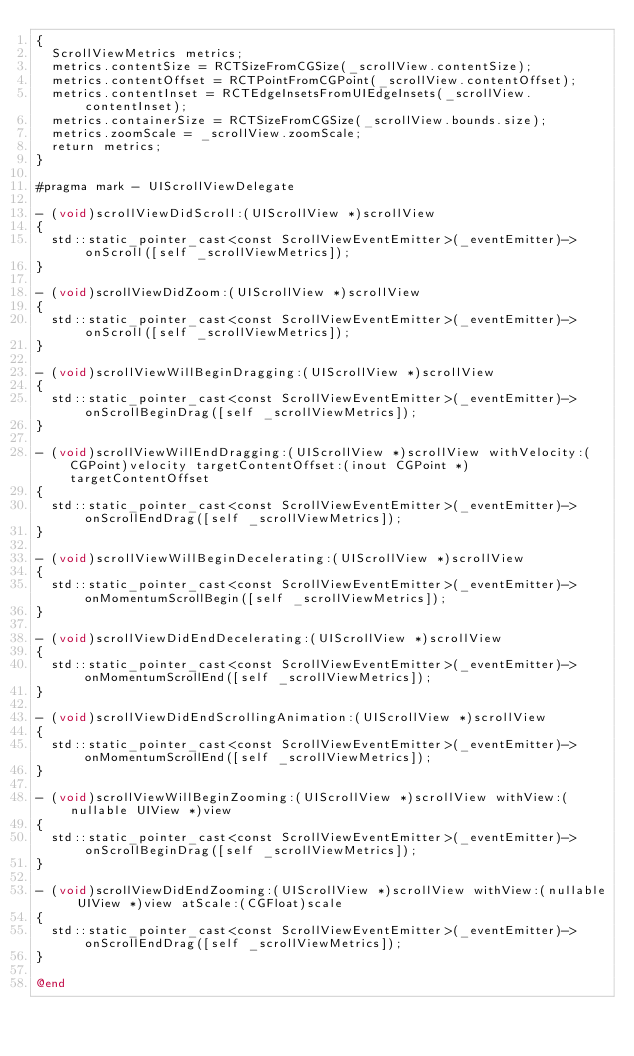Convert code to text. <code><loc_0><loc_0><loc_500><loc_500><_ObjectiveC_>{
  ScrollViewMetrics metrics;
  metrics.contentSize = RCTSizeFromCGSize(_scrollView.contentSize);
  metrics.contentOffset = RCTPointFromCGPoint(_scrollView.contentOffset);
  metrics.contentInset = RCTEdgeInsetsFromUIEdgeInsets(_scrollView.contentInset);
  metrics.containerSize = RCTSizeFromCGSize(_scrollView.bounds.size);
  metrics.zoomScale = _scrollView.zoomScale;
  return metrics;
}

#pragma mark - UIScrollViewDelegate

- (void)scrollViewDidScroll:(UIScrollView *)scrollView
{
  std::static_pointer_cast<const ScrollViewEventEmitter>(_eventEmitter)->onScroll([self _scrollViewMetrics]);
}

- (void)scrollViewDidZoom:(UIScrollView *)scrollView
{
  std::static_pointer_cast<const ScrollViewEventEmitter>(_eventEmitter)->onScroll([self _scrollViewMetrics]);
}

- (void)scrollViewWillBeginDragging:(UIScrollView *)scrollView
{
  std::static_pointer_cast<const ScrollViewEventEmitter>(_eventEmitter)->onScrollBeginDrag([self _scrollViewMetrics]);
}

- (void)scrollViewWillEndDragging:(UIScrollView *)scrollView withVelocity:(CGPoint)velocity targetContentOffset:(inout CGPoint *)targetContentOffset
{
  std::static_pointer_cast<const ScrollViewEventEmitter>(_eventEmitter)->onScrollEndDrag([self _scrollViewMetrics]);
}

- (void)scrollViewWillBeginDecelerating:(UIScrollView *)scrollView
{
  std::static_pointer_cast<const ScrollViewEventEmitter>(_eventEmitter)->onMomentumScrollBegin([self _scrollViewMetrics]);
}

- (void)scrollViewDidEndDecelerating:(UIScrollView *)scrollView
{
  std::static_pointer_cast<const ScrollViewEventEmitter>(_eventEmitter)->onMomentumScrollEnd([self _scrollViewMetrics]);
}

- (void)scrollViewDidEndScrollingAnimation:(UIScrollView *)scrollView
{
  std::static_pointer_cast<const ScrollViewEventEmitter>(_eventEmitter)->onMomentumScrollEnd([self _scrollViewMetrics]);
}

- (void)scrollViewWillBeginZooming:(UIScrollView *)scrollView withView:(nullable UIView *)view
{
  std::static_pointer_cast<const ScrollViewEventEmitter>(_eventEmitter)->onScrollBeginDrag([self _scrollViewMetrics]);
}

- (void)scrollViewDidEndZooming:(UIScrollView *)scrollView withView:(nullable UIView *)view atScale:(CGFloat)scale
{
  std::static_pointer_cast<const ScrollViewEventEmitter>(_eventEmitter)->onScrollEndDrag([self _scrollViewMetrics]);
}

@end
</code> 